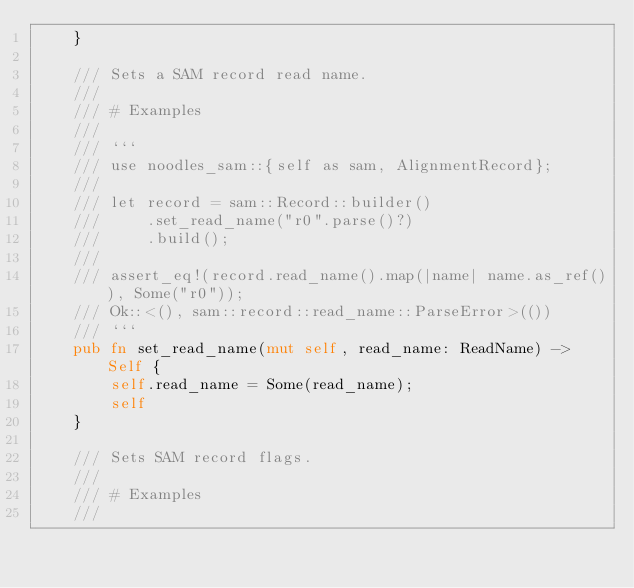Convert code to text. <code><loc_0><loc_0><loc_500><loc_500><_Rust_>    }

    /// Sets a SAM record read name.
    ///
    /// # Examples
    ///
    /// ```
    /// use noodles_sam::{self as sam, AlignmentRecord};
    ///
    /// let record = sam::Record::builder()
    ///     .set_read_name("r0".parse()?)
    ///     .build();
    ///
    /// assert_eq!(record.read_name().map(|name| name.as_ref()), Some("r0"));
    /// Ok::<(), sam::record::read_name::ParseError>(())
    /// ```
    pub fn set_read_name(mut self, read_name: ReadName) -> Self {
        self.read_name = Some(read_name);
        self
    }

    /// Sets SAM record flags.
    ///
    /// # Examples
    ///</code> 